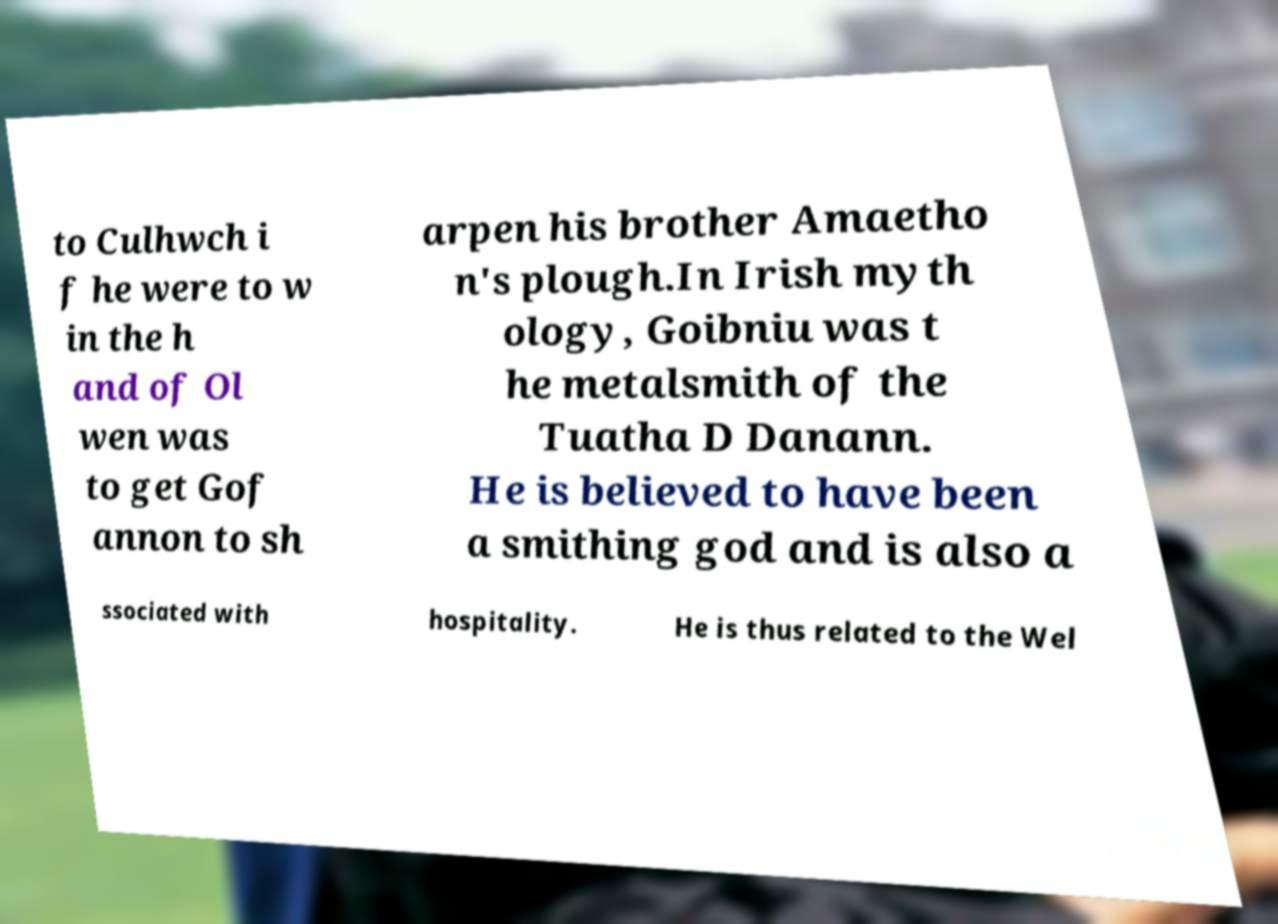I need the written content from this picture converted into text. Can you do that? to Culhwch i f he were to w in the h and of Ol wen was to get Gof annon to sh arpen his brother Amaetho n's plough.In Irish myth ology, Goibniu was t he metalsmith of the Tuatha D Danann. He is believed to have been a smithing god and is also a ssociated with hospitality. He is thus related to the Wel 